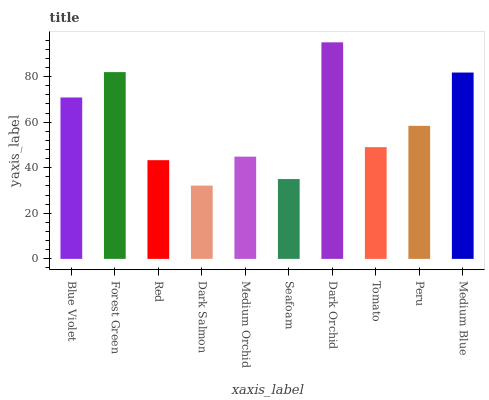Is Dark Salmon the minimum?
Answer yes or no. Yes. Is Dark Orchid the maximum?
Answer yes or no. Yes. Is Forest Green the minimum?
Answer yes or no. No. Is Forest Green the maximum?
Answer yes or no. No. Is Forest Green greater than Blue Violet?
Answer yes or no. Yes. Is Blue Violet less than Forest Green?
Answer yes or no. Yes. Is Blue Violet greater than Forest Green?
Answer yes or no. No. Is Forest Green less than Blue Violet?
Answer yes or no. No. Is Peru the high median?
Answer yes or no. Yes. Is Tomato the low median?
Answer yes or no. Yes. Is Medium Blue the high median?
Answer yes or no. No. Is Seafoam the low median?
Answer yes or no. No. 